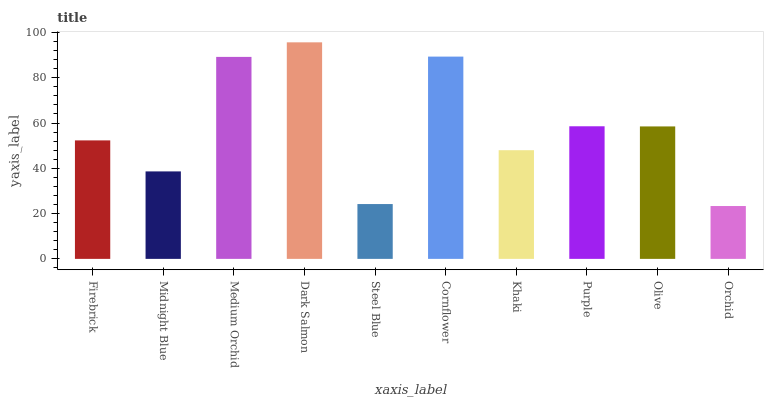Is Orchid the minimum?
Answer yes or no. Yes. Is Dark Salmon the maximum?
Answer yes or no. Yes. Is Midnight Blue the minimum?
Answer yes or no. No. Is Midnight Blue the maximum?
Answer yes or no. No. Is Firebrick greater than Midnight Blue?
Answer yes or no. Yes. Is Midnight Blue less than Firebrick?
Answer yes or no. Yes. Is Midnight Blue greater than Firebrick?
Answer yes or no. No. Is Firebrick less than Midnight Blue?
Answer yes or no. No. Is Olive the high median?
Answer yes or no. Yes. Is Firebrick the low median?
Answer yes or no. Yes. Is Orchid the high median?
Answer yes or no. No. Is Medium Orchid the low median?
Answer yes or no. No. 